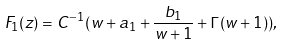Convert formula to latex. <formula><loc_0><loc_0><loc_500><loc_500>F _ { 1 } ( z ) = C ^ { - 1 } ( w + a _ { 1 } + \frac { b _ { 1 } } { w + 1 } + \Gamma ( w + 1 ) ) ,</formula> 